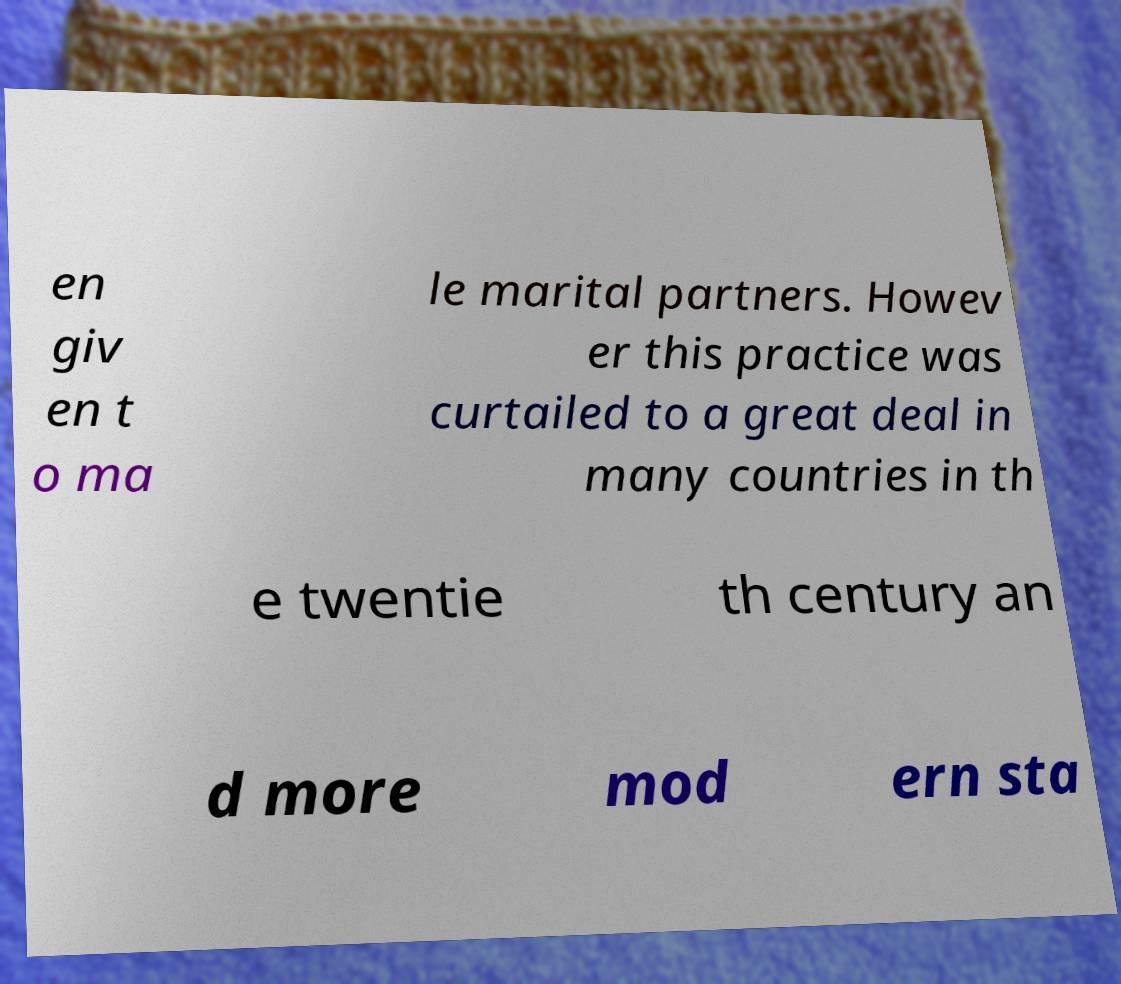Can you read and provide the text displayed in the image?This photo seems to have some interesting text. Can you extract and type it out for me? en giv en t o ma le marital partners. Howev er this practice was curtailed to a great deal in many countries in th e twentie th century an d more mod ern sta 